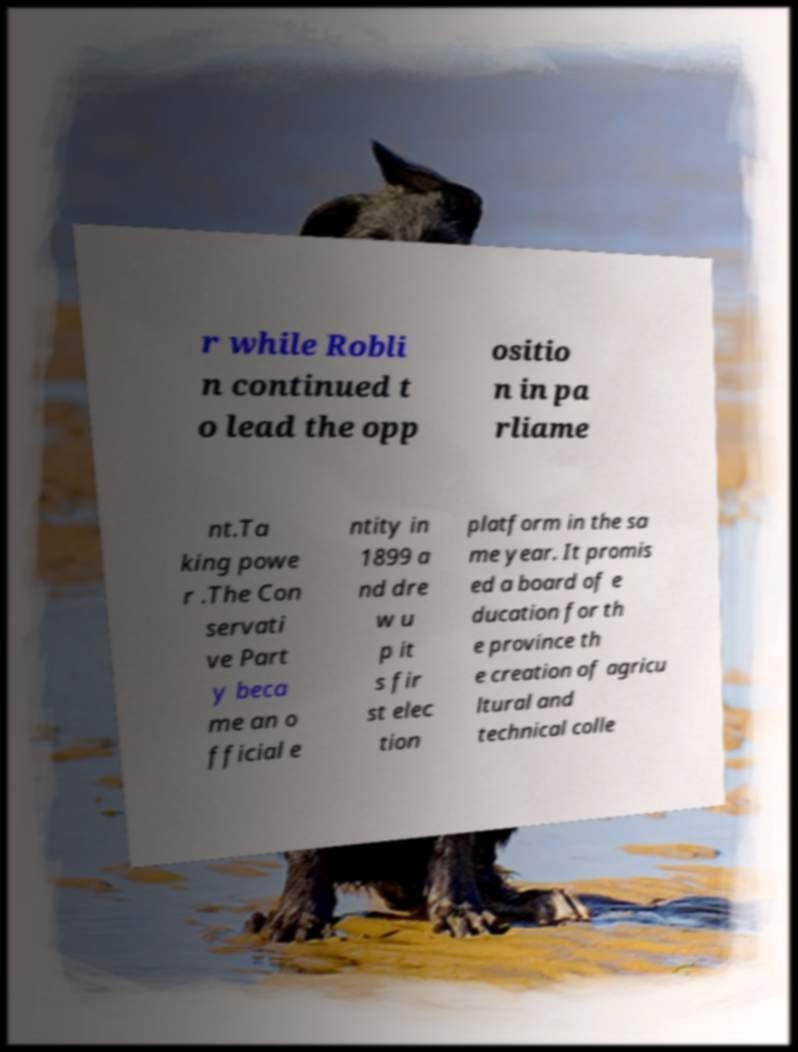Could you assist in decoding the text presented in this image and type it out clearly? r while Robli n continued t o lead the opp ositio n in pa rliame nt.Ta king powe r .The Con servati ve Part y beca me an o fficial e ntity in 1899 a nd dre w u p it s fir st elec tion platform in the sa me year. It promis ed a board of e ducation for th e province th e creation of agricu ltural and technical colle 